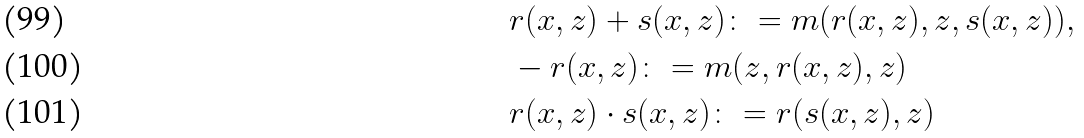<formula> <loc_0><loc_0><loc_500><loc_500>& r ( x , z ) + s ( x , z ) \colon = m ( r ( x , z ) , z , s ( x , z ) ) , \\ & - r ( x , z ) \colon = m ( z , r ( x , z ) , z ) \\ & r ( x , z ) \cdot s ( x , z ) \colon = r ( s ( x , z ) , z )</formula> 